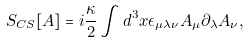Convert formula to latex. <formula><loc_0><loc_0><loc_500><loc_500>S _ { C S } [ A ] = i \frac { \kappa } { 2 } \int d ^ { 3 } x \epsilon _ { \mu \lambda \nu } A _ { \mu } \partial _ { \lambda } A _ { \nu } ,</formula> 